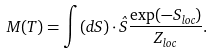Convert formula to latex. <formula><loc_0><loc_0><loc_500><loc_500>M ( T ) = \int ( d { S } ) \cdot \hat { S } \frac { \exp ( - S _ { l o c } ) } { Z _ { l o c } } .</formula> 